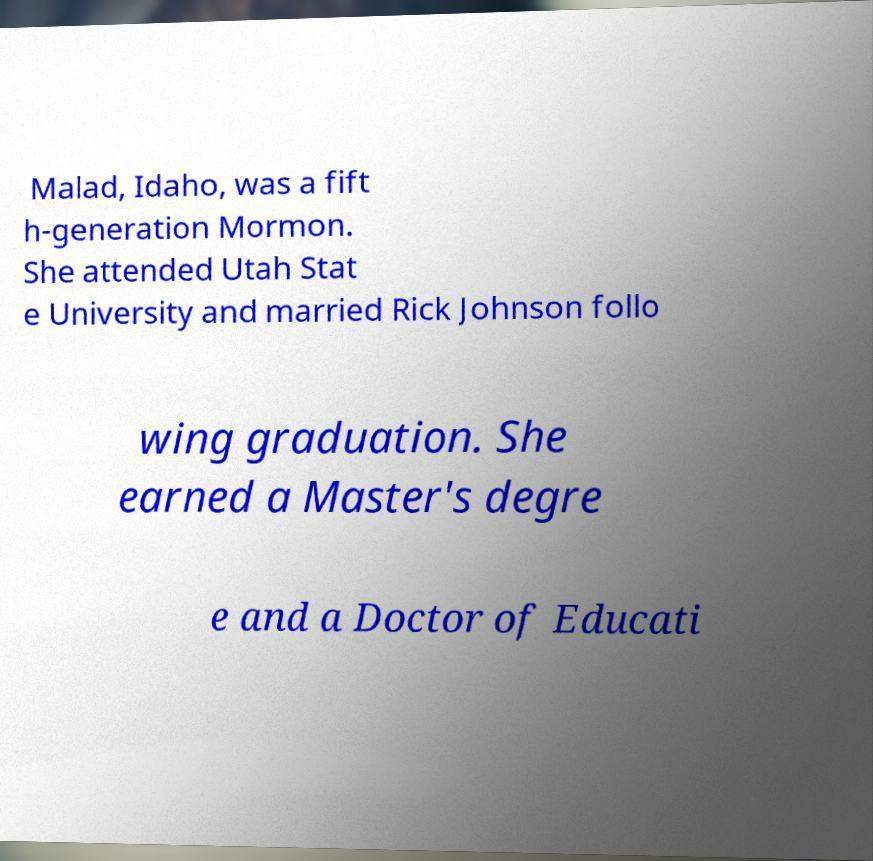Please identify and transcribe the text found in this image. Malad, Idaho, was a fift h-generation Mormon. She attended Utah Stat e University and married Rick Johnson follo wing graduation. She earned a Master's degre e and a Doctor of Educati 